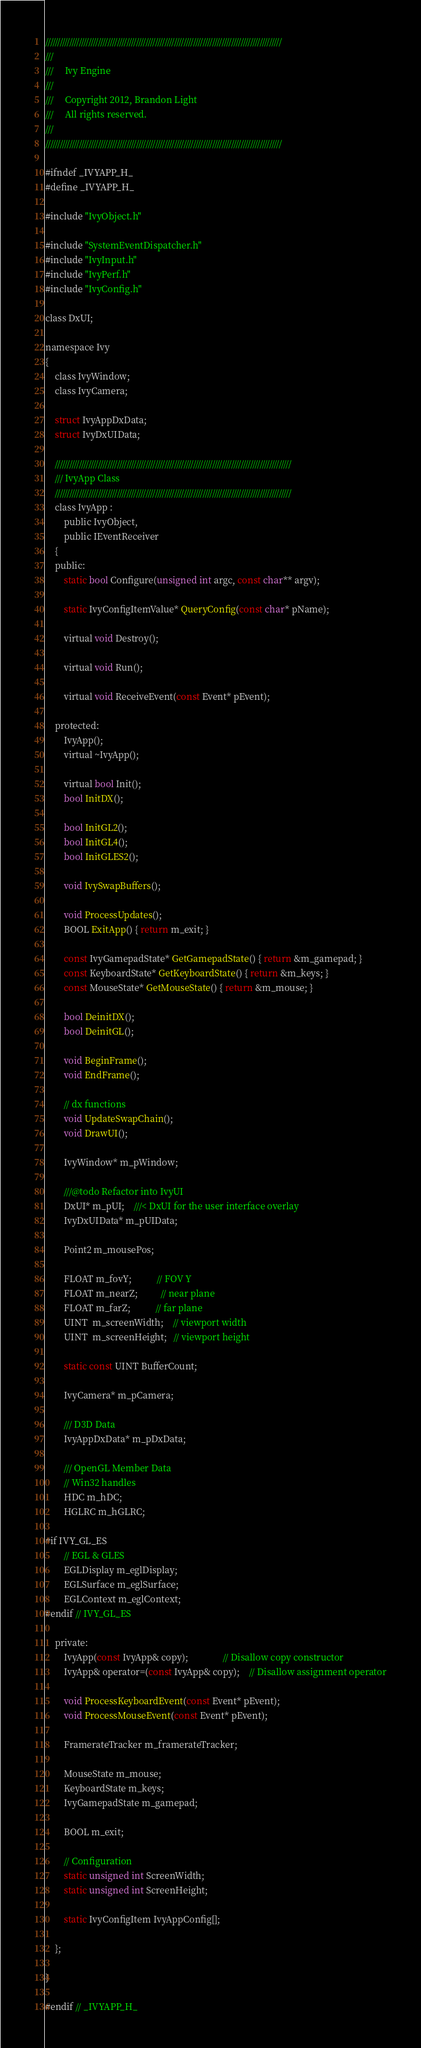Convert code to text. <code><loc_0><loc_0><loc_500><loc_500><_C_>///////////////////////////////////////////////////////////////////////////////////////////////////
///
///     Ivy Engine
///
///     Copyright 2012, Brandon Light
///     All rights reserved.
///
///////////////////////////////////////////////////////////////////////////////////////////////////

#ifndef _IVYAPP_H_
#define _IVYAPP_H_

#include "IvyObject.h"

#include "SystemEventDispatcher.h"
#include "IvyInput.h"
#include "IvyPerf.h"
#include "IvyConfig.h"

class DxUI;

namespace Ivy
{
    class IvyWindow;
    class IvyCamera;

    struct IvyAppDxData;
    struct IvyDxUIData;

    ///////////////////////////////////////////////////////////////////////////////////////////////////
    /// IvyApp Class
    ///////////////////////////////////////////////////////////////////////////////////////////////////
    class IvyApp :
        public IvyObject,
        public IEventReceiver
    {
    public:
        static bool Configure(unsigned int argc, const char** argv);

        static IvyConfigItemValue* QueryConfig(const char* pName);

        virtual void Destroy();

        virtual void Run();

        virtual void ReceiveEvent(const Event* pEvent);

    protected:
        IvyApp();
        virtual ~IvyApp();

        virtual bool Init();
        bool InitDX();

        bool InitGL2();
        bool InitGL4();
        bool InitGLES2();

        void IvySwapBuffers();

        void ProcessUpdates();
        BOOL ExitApp() { return m_exit; }

        const IvyGamepadState* GetGamepadState() { return &m_gamepad; }
        const KeyboardState* GetKeyboardState() { return &m_keys; }
        const MouseState* GetMouseState() { return &m_mouse; }

        bool DeinitDX();
        bool DeinitGL();

        void BeginFrame();
        void EndFrame();

        // dx functions
        void UpdateSwapChain();
        void DrawUI();

        IvyWindow* m_pWindow;

        ///@todo Refactor into IvyUI
        DxUI* m_pUI;    ///< DxUI for the user interface overlay
        IvyDxUIData* m_pUIData;

        Point2 m_mousePos;

        FLOAT m_fovY;           // FOV Y
        FLOAT m_nearZ;          // near plane
        FLOAT m_farZ;           // far plane
        UINT  m_screenWidth;    // viewport width
        UINT  m_screenHeight;   // viewport height

        static const UINT BufferCount;

        IvyCamera* m_pCamera;

        /// D3D Data
        IvyAppDxData* m_pDxData;

        /// OpenGL Member Data
        // Win32 handles
        HDC m_hDC;
        HGLRC m_hGLRC;

#if IVY_GL_ES
        // EGL & GLES
        EGLDisplay m_eglDisplay;
        EGLSurface m_eglSurface;
        EGLContext m_eglContext;
#endif // IVY_GL_ES

    private:
        IvyApp(const IvyApp& copy);               // Disallow copy constructor
        IvyApp& operator=(const IvyApp& copy);    // Disallow assignment operator

        void ProcessKeyboardEvent(const Event* pEvent);
        void ProcessMouseEvent(const Event* pEvent);

        FramerateTracker m_framerateTracker;

        MouseState m_mouse;
        KeyboardState m_keys;
        IvyGamepadState m_gamepad;

        BOOL m_exit;

        // Configuration
        static unsigned int ScreenWidth;
        static unsigned int ScreenHeight;

        static IvyConfigItem IvyAppConfig[];

    };

}

#endif // _IVYAPP_H_

</code> 